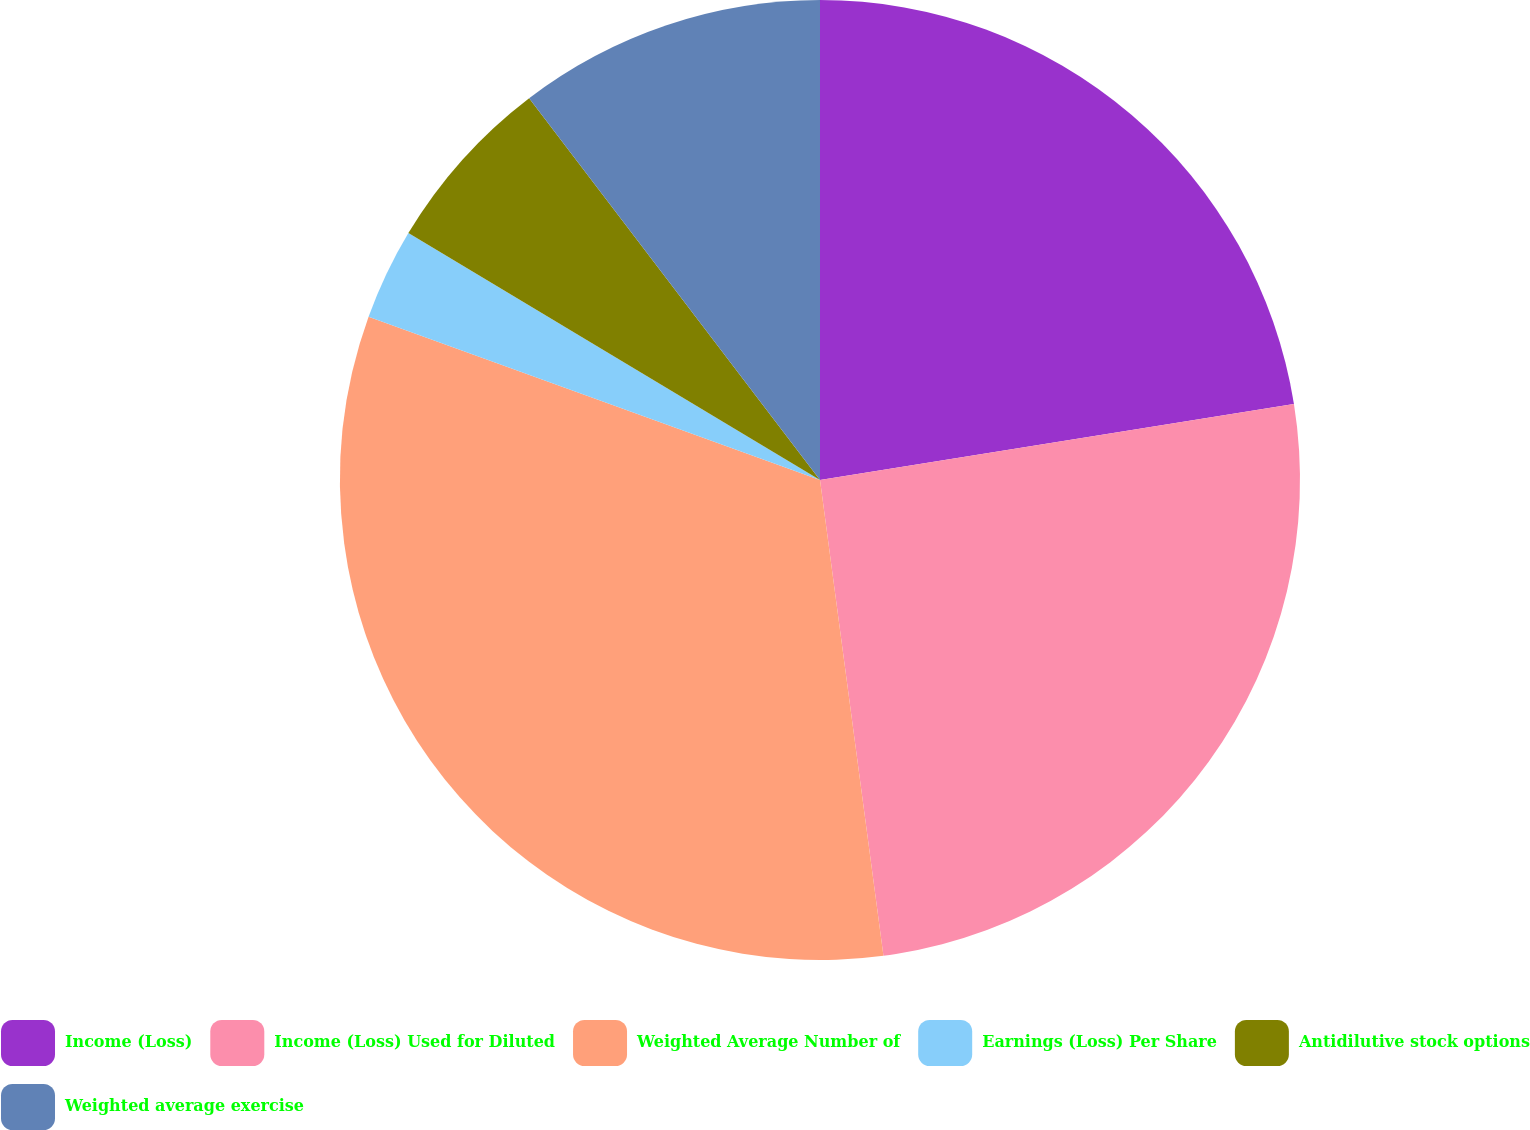Convert chart. <chart><loc_0><loc_0><loc_500><loc_500><pie_chart><fcel>Income (Loss)<fcel>Income (Loss) Used for Diluted<fcel>Weighted Average Number of<fcel>Earnings (Loss) Per Share<fcel>Antidilutive stock options<fcel>Weighted average exercise<nl><fcel>22.47%<fcel>25.42%<fcel>32.63%<fcel>3.08%<fcel>6.04%<fcel>10.36%<nl></chart> 